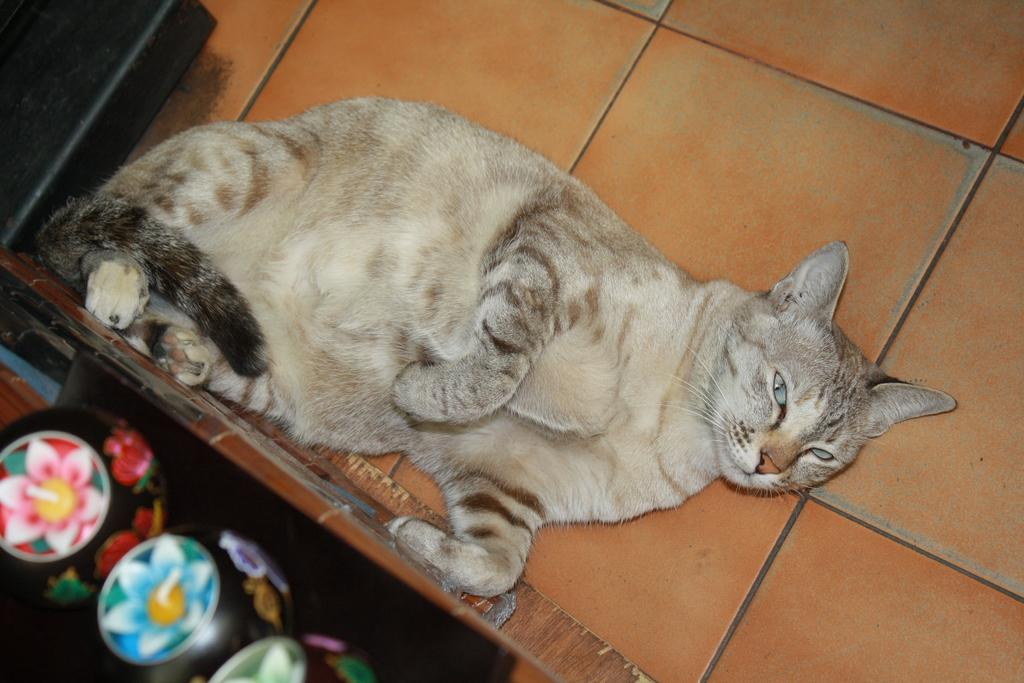What animal can be seen lying on the floor in the image? There is a cat lying on the floor in the image. What is located at the bottom left corner of the image? There are objects in a box on the left side at the bottom corner of the image. What is situated at the top of the image? There is an object on the floor at the top of the image. How many icicles are hanging from the cat's whiskers in the image? There are no icicles present in the image, as it features a cat lying on the floor and objects in a box. 